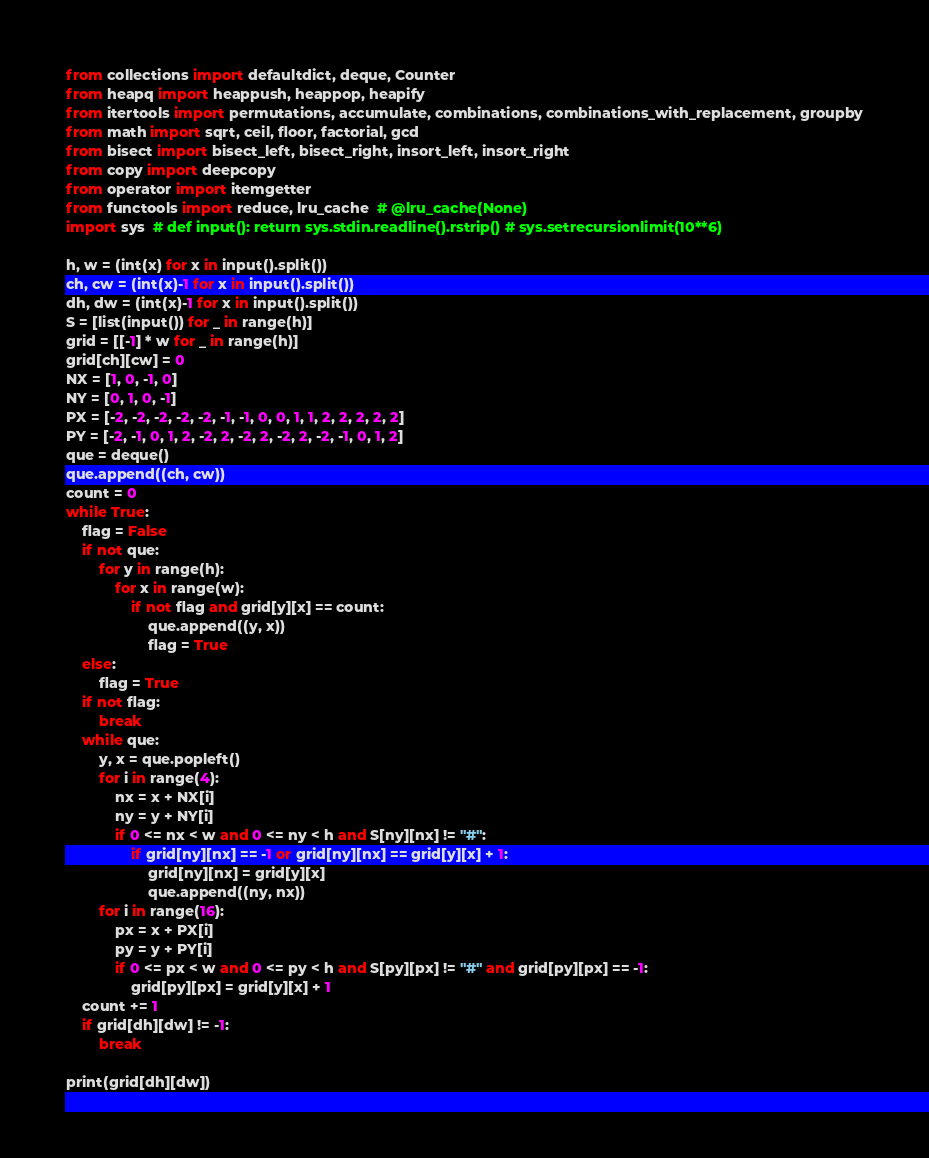<code> <loc_0><loc_0><loc_500><loc_500><_Python_>from collections import defaultdict, deque, Counter
from heapq import heappush, heappop, heapify
from itertools import permutations, accumulate, combinations, combinations_with_replacement, groupby
from math import sqrt, ceil, floor, factorial, gcd
from bisect import bisect_left, bisect_right, insort_left, insort_right
from copy import deepcopy
from operator import itemgetter
from functools import reduce, lru_cache  # @lru_cache(None)
import sys  # def input(): return sys.stdin.readline().rstrip() # sys.setrecursionlimit(10**6)

h, w = (int(x) for x in input().split())
ch, cw = (int(x)-1 for x in input().split())
dh, dw = (int(x)-1 for x in input().split())
S = [list(input()) for _ in range(h)]
grid = [[-1] * w for _ in range(h)]
grid[ch][cw] = 0
NX = [1, 0, -1, 0]
NY = [0, 1, 0, -1]
PX = [-2, -2, -2, -2, -2, -1, -1, 0, 0, 1, 1, 2, 2, 2, 2, 2]
PY = [-2, -1, 0, 1, 2, -2, 2, -2, 2, -2, 2, -2, -1, 0, 1, 2]
que = deque()
que.append((ch, cw))
count = 0
while True:
    flag = False
    if not que:
        for y in range(h):
            for x in range(w):
                if not flag and grid[y][x] == count:
                    que.append((y, x))
                    flag = True
    else:
        flag = True
    if not flag:
        break
    while que:
        y, x = que.popleft()
        for i in range(4):
            nx = x + NX[i]
            ny = y + NY[i]
            if 0 <= nx < w and 0 <= ny < h and S[ny][nx] != "#":
                if grid[ny][nx] == -1 or grid[ny][nx] == grid[y][x] + 1:
                    grid[ny][nx] = grid[y][x]
                    que.append((ny, nx))
        for i in range(16):
            px = x + PX[i]
            py = y + PY[i]
            if 0 <= px < w and 0 <= py < h and S[py][px] != "#" and grid[py][px] == -1:
                grid[py][px] = grid[y][x] + 1
    count += 1
    if grid[dh][dw] != -1:
        break

print(grid[dh][dw])
</code> 